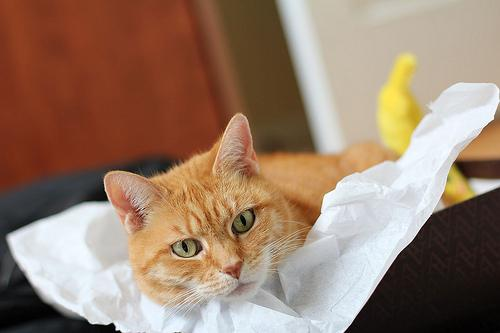Question: what color are the cats eyes?
Choices:
A. Dark green.
B. Light green.
C. Light blue.
D. Dark Brown.
Answer with the letter. Answer: B Question: what is the cat laying on?
Choices:
A. A blanket.
B. The laptop.
C. The window ledge.
D. Paper towel.
Answer with the letter. Answer: D Question: where is a yellow blurry object?
Choices:
A. In the air.
B. On the tv.
C. Behind cat.
D. On the grandfather clock.
Answer with the letter. Answer: C 